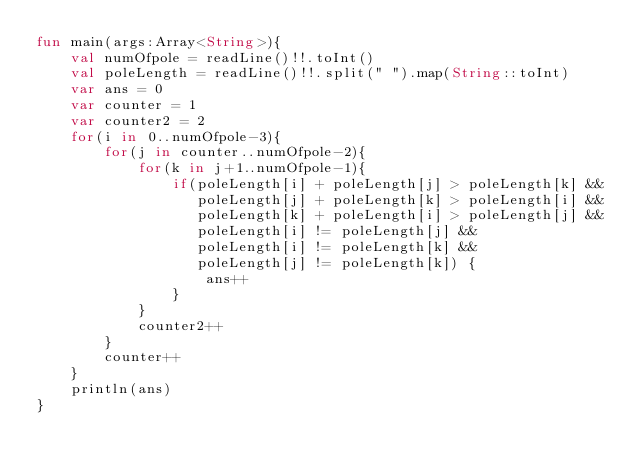Convert code to text. <code><loc_0><loc_0><loc_500><loc_500><_Kotlin_>fun main(args:Array<String>){
    val numOfpole = readLine()!!.toInt()
    val poleLength = readLine()!!.split(" ").map(String::toInt)
    var ans = 0
    var counter = 1
    var counter2 = 2
    for(i in 0..numOfpole-3){
        for(j in counter..numOfpole-2){
            for(k in j+1..numOfpole-1){
                if(poleLength[i] + poleLength[j] > poleLength[k] &&
                   poleLength[j] + poleLength[k] > poleLength[i] &&
                   poleLength[k] + poleLength[i] > poleLength[j] &&
                   poleLength[i] != poleLength[j] &&
                   poleLength[i] != poleLength[k] && 
                   poleLength[j] != poleLength[k]) {
                    ans++
                }
            }
            counter2++
        }
        counter++
    }
    println(ans)
}</code> 